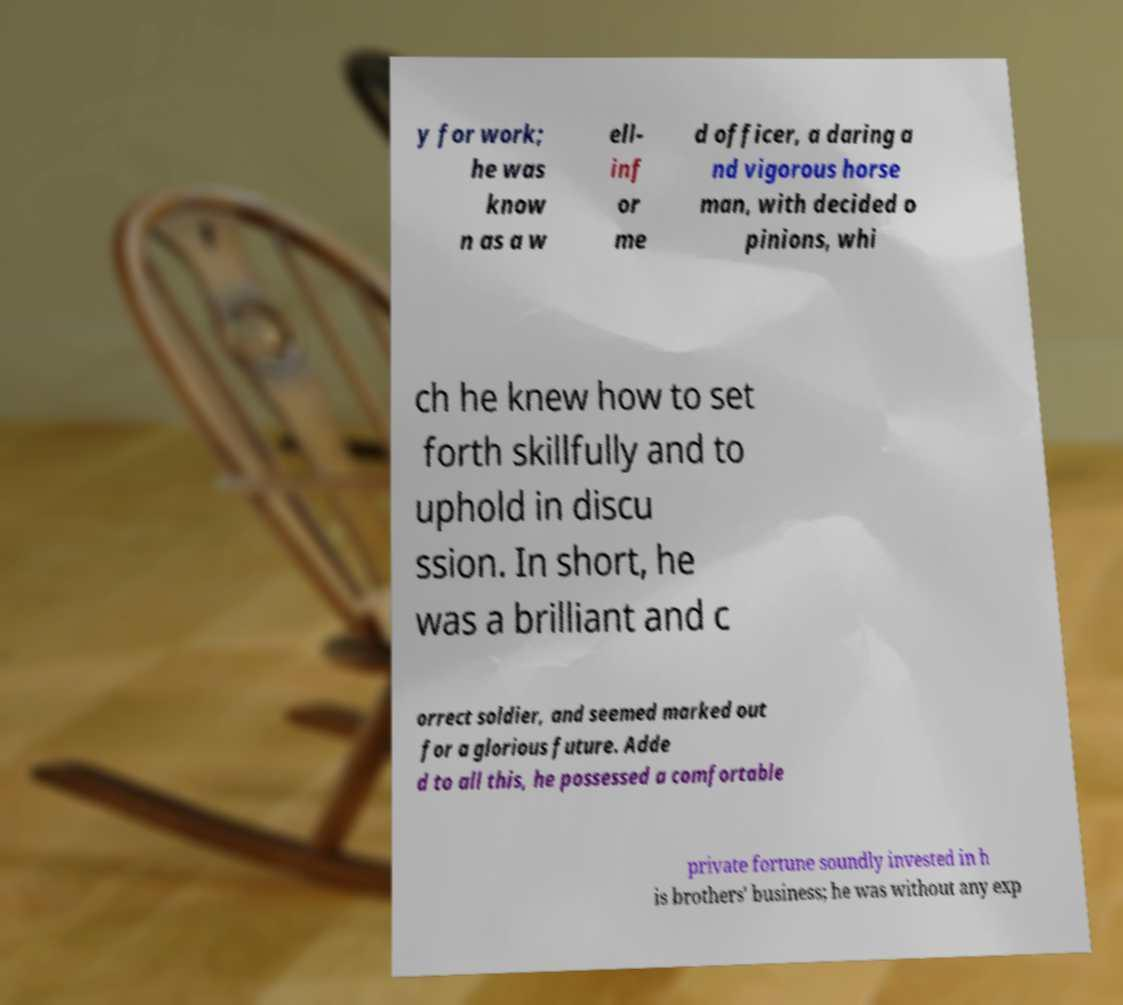Could you extract and type out the text from this image? y for work; he was know n as a w ell- inf or me d officer, a daring a nd vigorous horse man, with decided o pinions, whi ch he knew how to set forth skillfully and to uphold in discu ssion. In short, he was a brilliant and c orrect soldier, and seemed marked out for a glorious future. Adde d to all this, he possessed a comfortable private fortune soundly invested in h is brothers' business; he was without any exp 